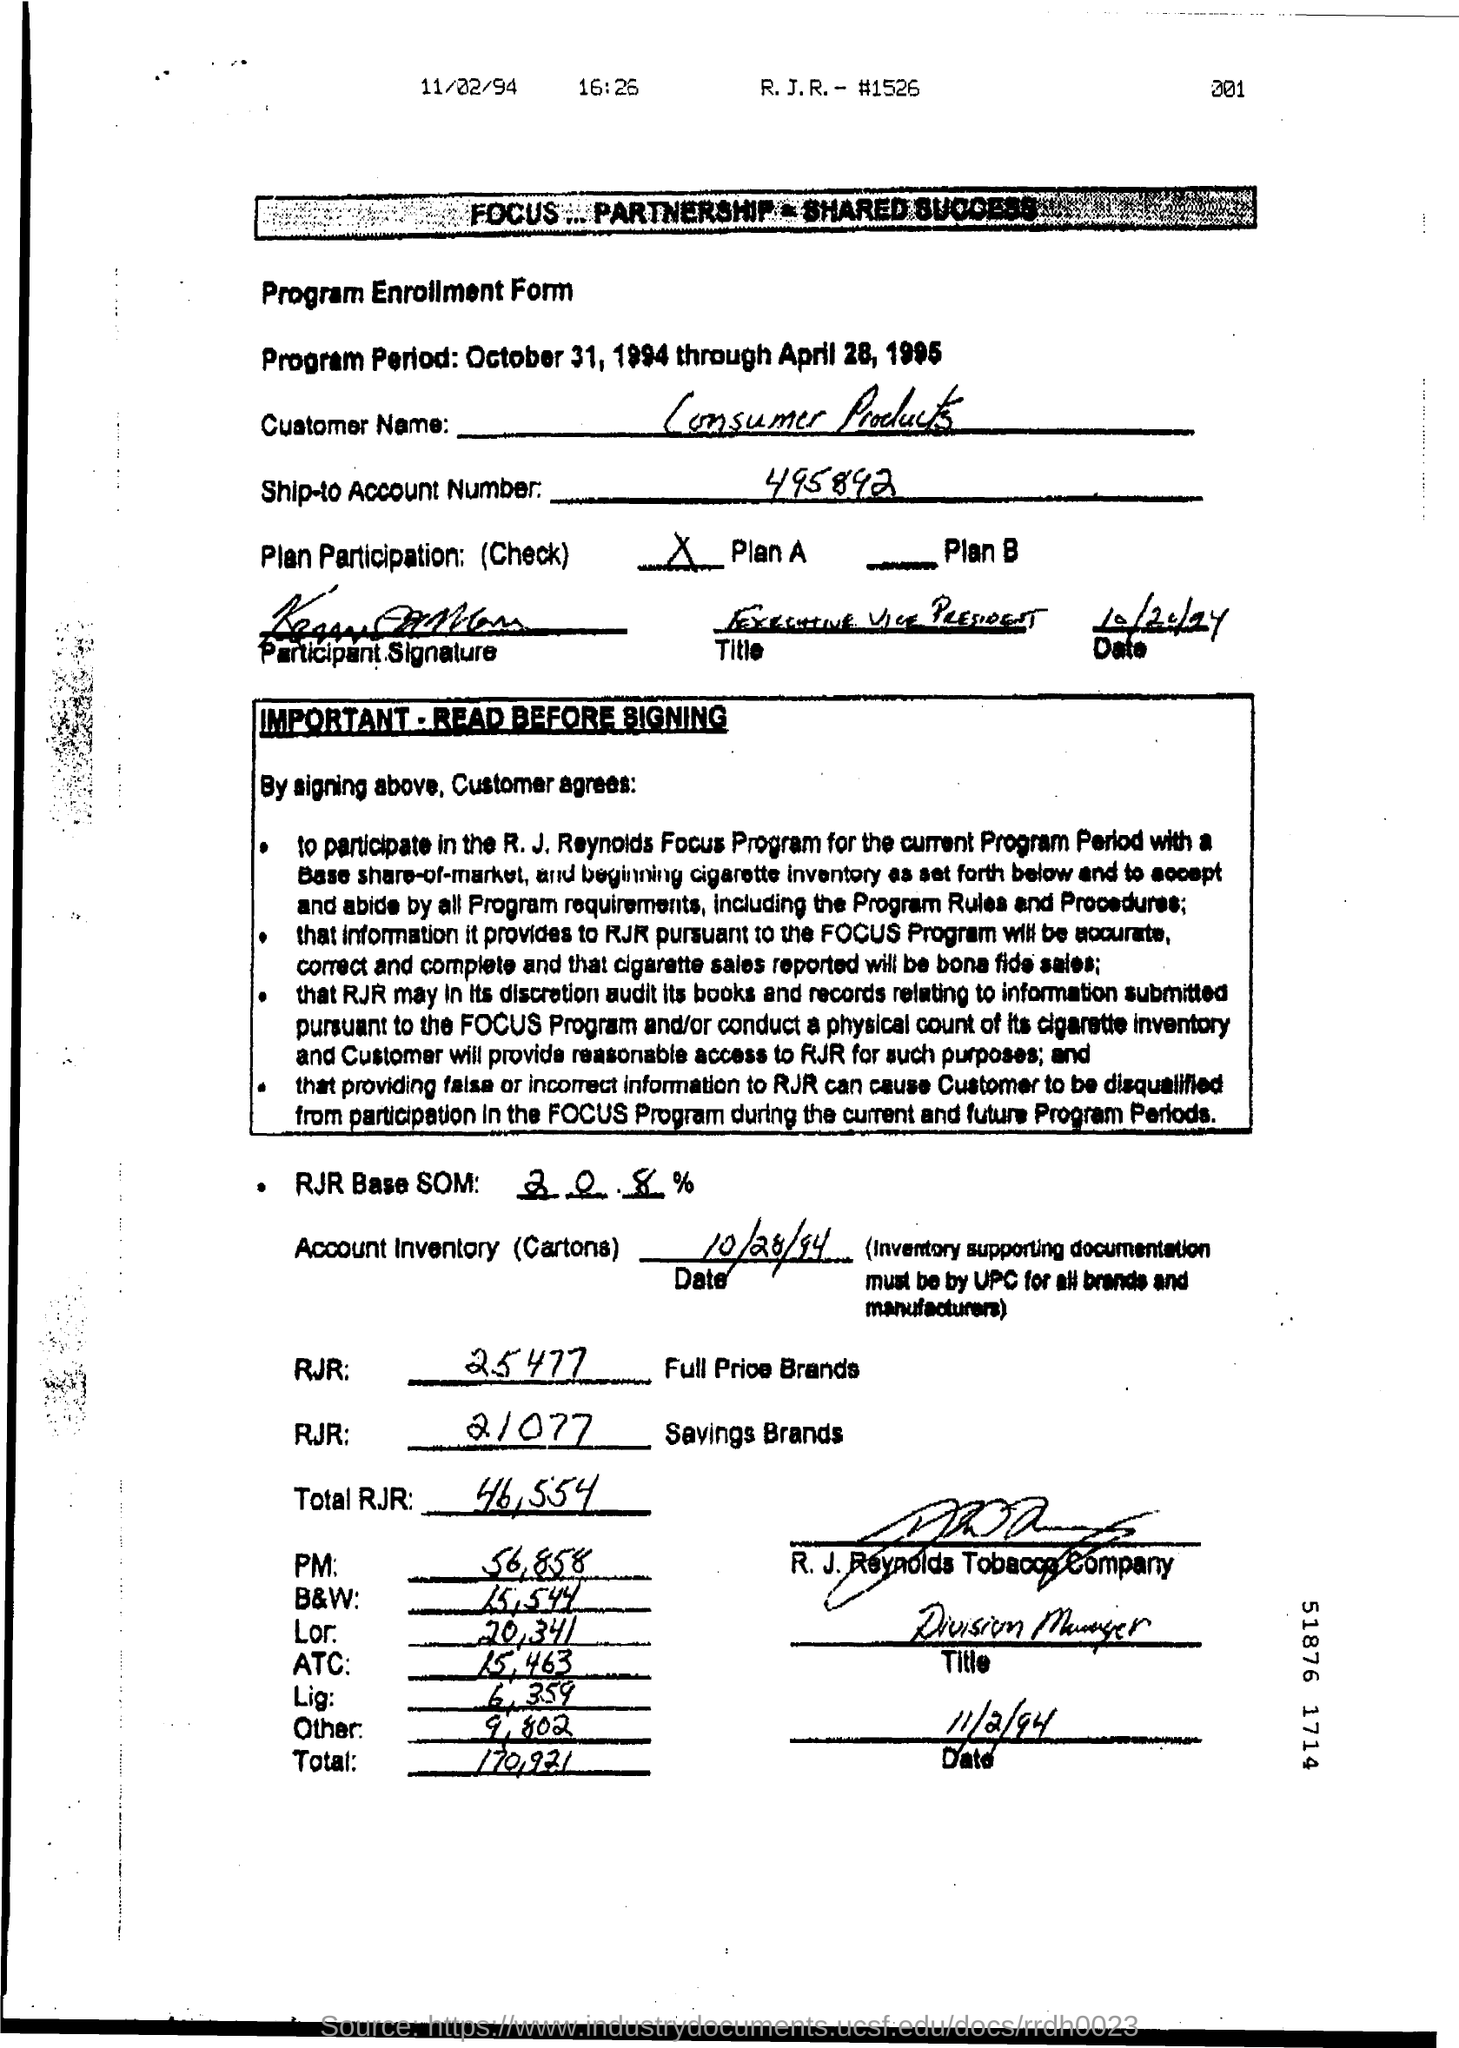Mention a couple of crucial points in this snapshot. The program period mentioned in the form is from October 31, 1994 to April 28, 1995. The date mentioned at the bottom of the document is 11/2/94. The value in the "Other Field" is 9,802. The RJR field indicates a full price brand with a value of 25477. The Account Inventory Date is October 28, 1994. 